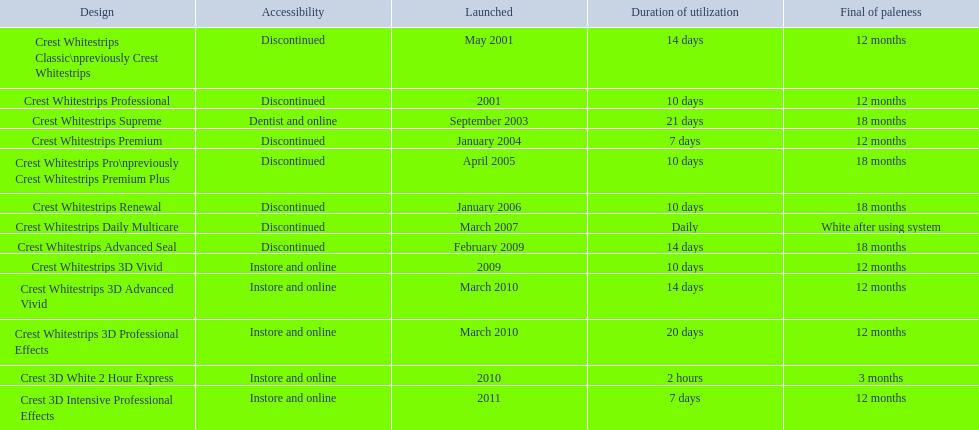Which of these products are discontinued? Crest Whitestrips Classic\npreviously Crest Whitestrips, Crest Whitestrips Professional, Crest Whitestrips Premium, Crest Whitestrips Pro\npreviously Crest Whitestrips Premium Plus, Crest Whitestrips Renewal, Crest Whitestrips Daily Multicare, Crest Whitestrips Advanced Seal. Which of these products have a 14 day length of use? Crest Whitestrips Classic\npreviously Crest Whitestrips, Crest Whitestrips Advanced Seal. Which of these products was introduced in 2009? Crest Whitestrips Advanced Seal. 